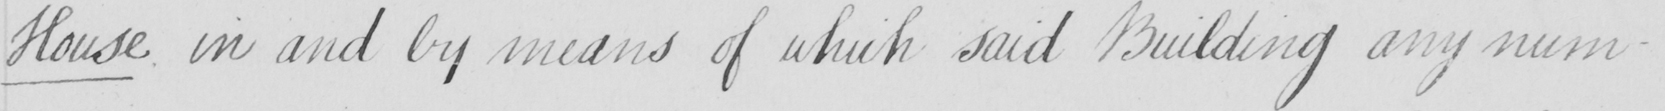What is written in this line of handwriting? House in and by means of which said Building any num- 